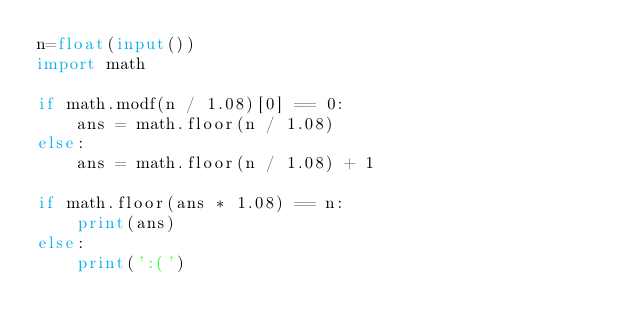Convert code to text. <code><loc_0><loc_0><loc_500><loc_500><_Python_>n=float(input())
import math

if math.modf(n / 1.08)[0] == 0:
    ans = math.floor(n / 1.08)
else:
    ans = math.floor(n / 1.08) + 1

if math.floor(ans * 1.08) == n:
    print(ans)
else:
    print(':(')</code> 